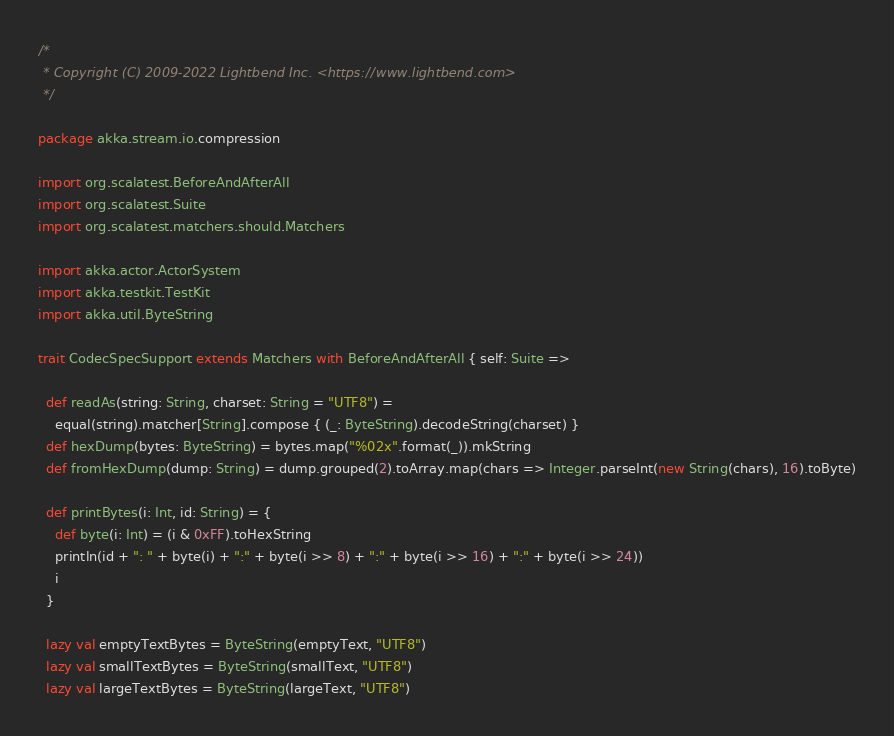Convert code to text. <code><loc_0><loc_0><loc_500><loc_500><_Scala_>/*
 * Copyright (C) 2009-2022 Lightbend Inc. <https://www.lightbend.com>
 */

package akka.stream.io.compression

import org.scalatest.BeforeAndAfterAll
import org.scalatest.Suite
import org.scalatest.matchers.should.Matchers

import akka.actor.ActorSystem
import akka.testkit.TestKit
import akka.util.ByteString

trait CodecSpecSupport extends Matchers with BeforeAndAfterAll { self: Suite =>

  def readAs(string: String, charset: String = "UTF8") =
    equal(string).matcher[String].compose { (_: ByteString).decodeString(charset) }
  def hexDump(bytes: ByteString) = bytes.map("%02x".format(_)).mkString
  def fromHexDump(dump: String) = dump.grouped(2).toArray.map(chars => Integer.parseInt(new String(chars), 16).toByte)

  def printBytes(i: Int, id: String) = {
    def byte(i: Int) = (i & 0xFF).toHexString
    println(id + ": " + byte(i) + ":" + byte(i >> 8) + ":" + byte(i >> 16) + ":" + byte(i >> 24))
    i
  }

  lazy val emptyTextBytes = ByteString(emptyText, "UTF8")
  lazy val smallTextBytes = ByteString(smallText, "UTF8")
  lazy val largeTextBytes = ByteString(largeText, "UTF8")
</code> 